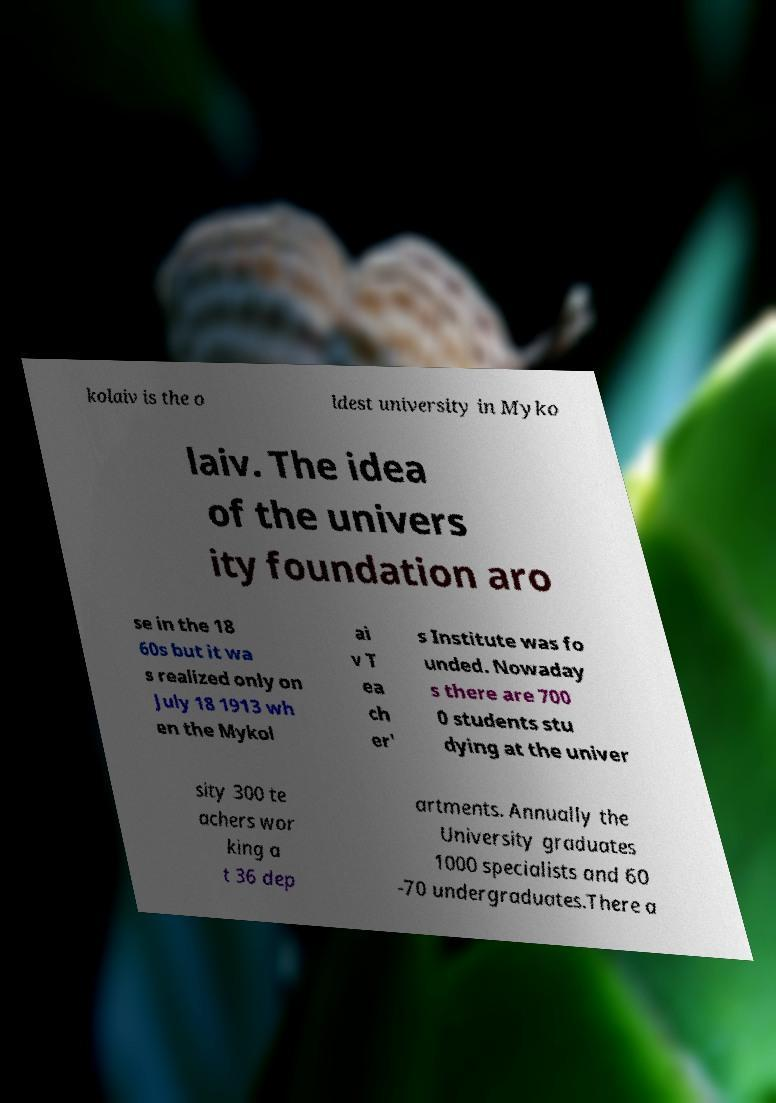Please identify and transcribe the text found in this image. kolaiv is the o ldest university in Myko laiv. The idea of the univers ity foundation aro se in the 18 60s but it wa s realized only on July 18 1913 wh en the Mykol ai v T ea ch er' s Institute was fo unded. Nowaday s there are 700 0 students stu dying at the univer sity 300 te achers wor king a t 36 dep artments. Annually the University graduates 1000 specialists and 60 -70 undergraduates.There a 